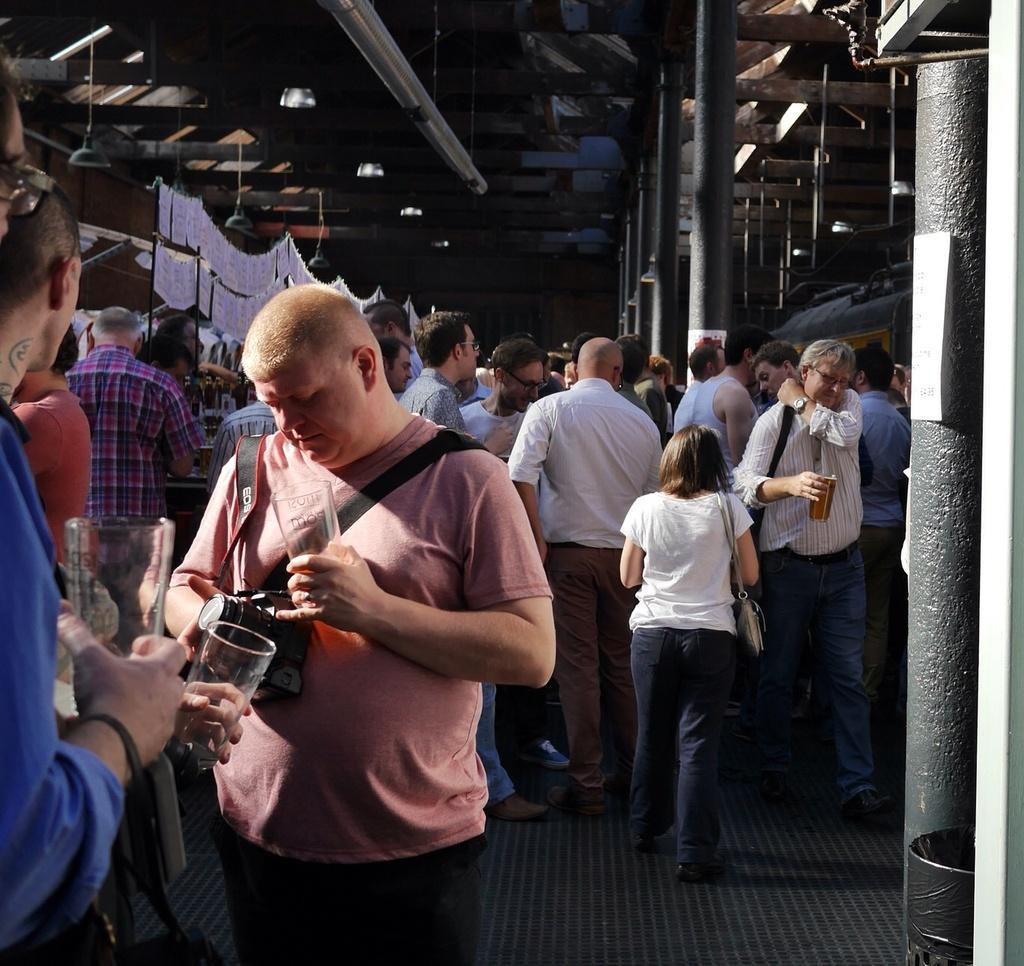In one or two sentences, can you explain what this image depicts? In this image I can see group of people standing. The person in front wearing peach color shirt, black pant and holding a glass. Background I can see a white color cloth and few lights. 